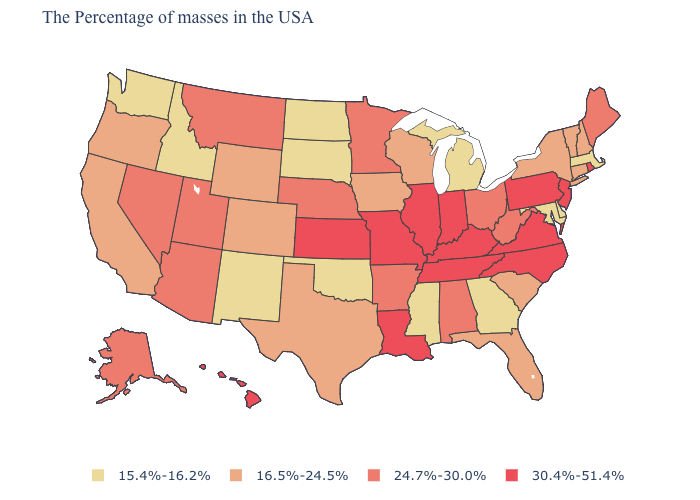Does Massachusetts have the lowest value in the Northeast?
Quick response, please. Yes. Name the states that have a value in the range 16.5%-24.5%?
Give a very brief answer. New Hampshire, Vermont, Connecticut, New York, South Carolina, Florida, Wisconsin, Iowa, Texas, Wyoming, Colorado, California, Oregon. Name the states that have a value in the range 15.4%-16.2%?
Write a very short answer. Massachusetts, Delaware, Maryland, Georgia, Michigan, Mississippi, Oklahoma, South Dakota, North Dakota, New Mexico, Idaho, Washington. What is the value of New York?
Be succinct. 16.5%-24.5%. What is the value of New Jersey?
Write a very short answer. 30.4%-51.4%. Does Washington have the lowest value in the USA?
Short answer required. Yes. Name the states that have a value in the range 16.5%-24.5%?
Short answer required. New Hampshire, Vermont, Connecticut, New York, South Carolina, Florida, Wisconsin, Iowa, Texas, Wyoming, Colorado, California, Oregon. Name the states that have a value in the range 15.4%-16.2%?
Write a very short answer. Massachusetts, Delaware, Maryland, Georgia, Michigan, Mississippi, Oklahoma, South Dakota, North Dakota, New Mexico, Idaho, Washington. Among the states that border Oregon , does Washington have the highest value?
Quick response, please. No. Among the states that border Indiana , which have the highest value?
Give a very brief answer. Kentucky, Illinois. Does Montana have a lower value than Missouri?
Answer briefly. Yes. Does Maryland have the lowest value in the USA?
Be succinct. Yes. What is the lowest value in the MidWest?
Be succinct. 15.4%-16.2%. Does Michigan have the highest value in the USA?
Be succinct. No. Name the states that have a value in the range 30.4%-51.4%?
Give a very brief answer. Rhode Island, New Jersey, Pennsylvania, Virginia, North Carolina, Kentucky, Indiana, Tennessee, Illinois, Louisiana, Missouri, Kansas, Hawaii. 